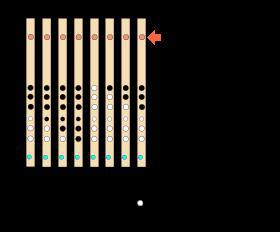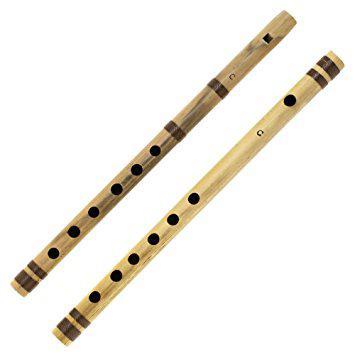The first image is the image on the left, the second image is the image on the right. For the images displayed, is the sentence "The right image shows a row of flutes with red stripes arranged in size order, with one end aligned." factually correct? Answer yes or no. No. The first image is the image on the left, the second image is the image on the right. For the images displayed, is the sentence "At least 10 flutes are placed sided by side in each picture." factually correct? Answer yes or no. No. 